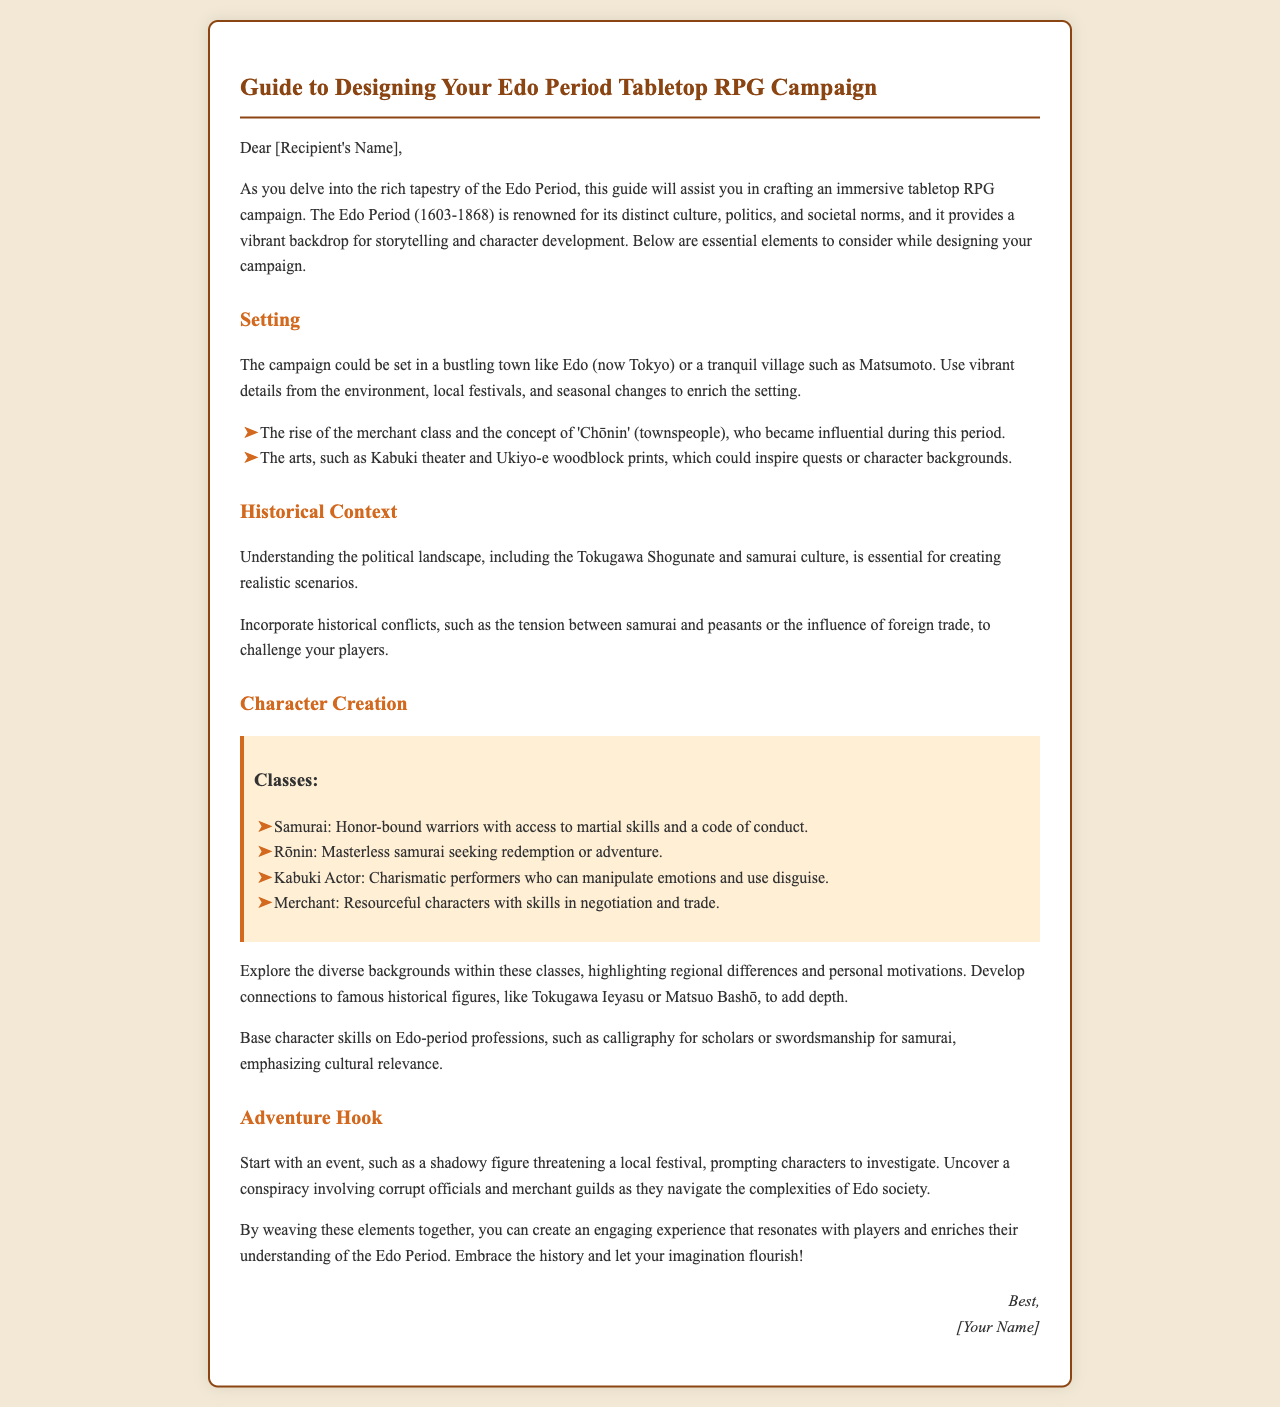What is the time period covered in the campaign? The document specifies that the Edo Period is from 1603 to 1868.
Answer: 1603-1868 What is the name of the influential class during this period? The document mentions the 'Chōnin' (townspeople) as the influential class.
Answer: Chōnin What can be a starting event for the adventure? The document suggests starting with a shadowy figure threatening a local festival.
Answer: Shadowy figure threatening a local festival What are two classes mentioned in character creation? The document lists Samurai and Merchant among the character classes.
Answer: Samurai, Merchant Who is one of the historical figures suggested for character connections? The document recommends connecting to Tokugawa Ieyasu for character development.
Answer: Tokugawa Ieyasu What type of performer is highlighted in the character classes? The document includes Kabuki Actor as one of the character classes.
Answer: Kabuki Actor What should be emphasized in character skills according to the document? The document states that character skills should be based on Edo-period professions.
Answer: Edo-period professions What is the primary focus of the document? The document is a guide for designing a tabletop RPG campaign set in the Edo Period.
Answer: Guide for designing a tabletop RPG campaign 